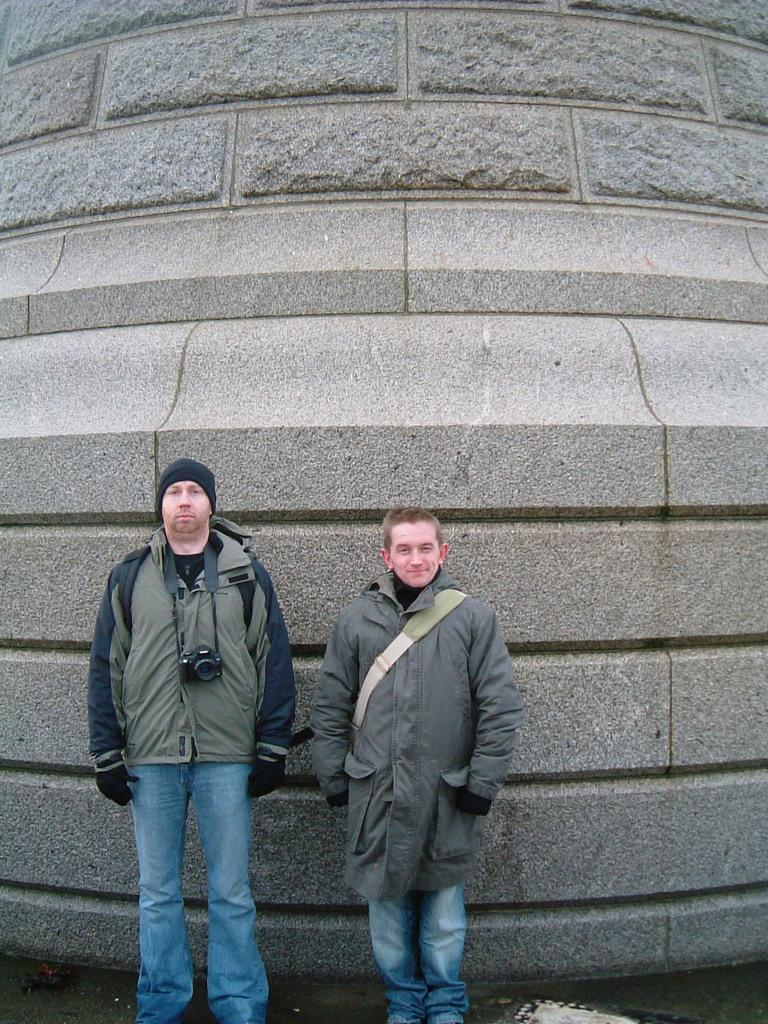How many people are present in the image? There are two men in the image. What object can be seen in the image that is commonly used for capturing images? There is a camera in the image. What is visible in the background of the image? There is a wall in the background of the image. What type of balloon is being used by the men in the image? There is no balloon present in the image. How does the behavior of the men in the image reflect their mood? The image does not provide enough information to determine the mood or behavior of the men. 